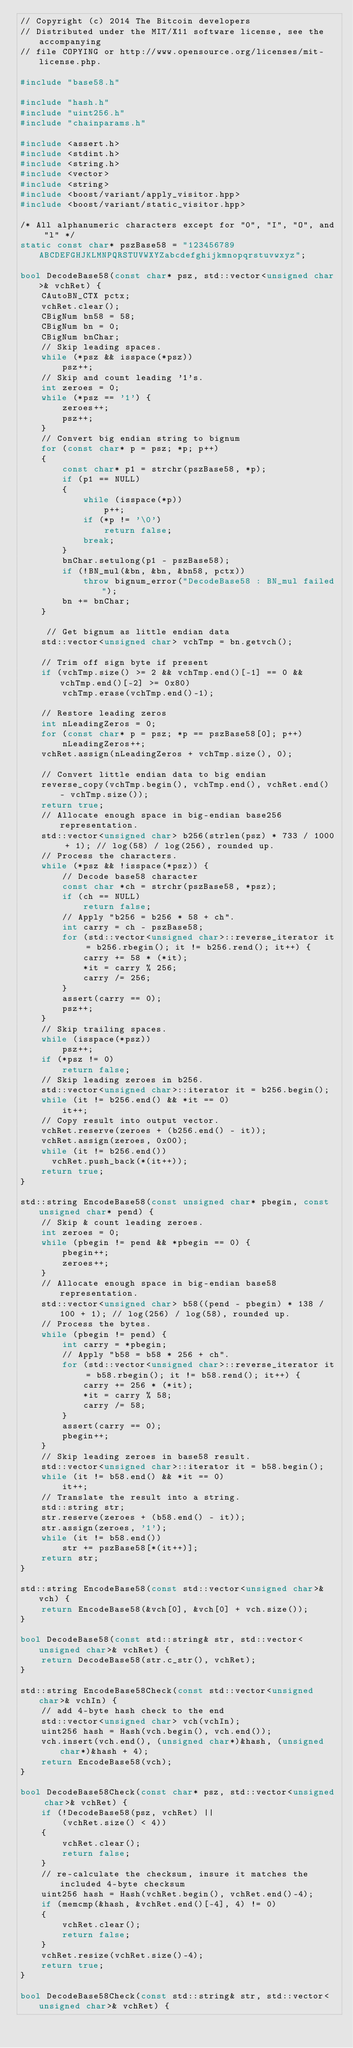<code> <loc_0><loc_0><loc_500><loc_500><_C++_>// Copyright (c) 2014 The Bitcoin developers
// Distributed under the MIT/X11 software license, see the accompanying
// file COPYING or http://www.opensource.org/licenses/mit-license.php.

#include "base58.h"

#include "hash.h"
#include "uint256.h"
#include "chainparams.h"

#include <assert.h>
#include <stdint.h>
#include <string.h>
#include <vector>
#include <string>
#include <boost/variant/apply_visitor.hpp>
#include <boost/variant/static_visitor.hpp>

/* All alphanumeric characters except for "0", "I", "O", and "l" */
static const char* pszBase58 = "123456789ABCDEFGHJKLMNPQRSTUVWXYZabcdefghijkmnopqrstuvwxyz";

bool DecodeBase58(const char* psz, std::vector<unsigned char>& vchRet) {
    CAutoBN_CTX pctx;
    vchRet.clear();
    CBigNum bn58 = 58;
    CBigNum bn = 0;
    CBigNum bnChar;
    // Skip leading spaces.
    while (*psz && isspace(*psz))
        psz++;
    // Skip and count leading '1's.
    int zeroes = 0;
    while (*psz == '1') {
        zeroes++;
        psz++;
    }
    // Convert big endian string to bignum
    for (const char* p = psz; *p; p++)
    {
        const char* p1 = strchr(pszBase58, *p);
        if (p1 == NULL)
        {
            while (isspace(*p))
                p++;
            if (*p != '\0')
                return false;
            break;
        }
        bnChar.setulong(p1 - pszBase58);
        if (!BN_mul(&bn, &bn, &bn58, pctx))
            throw bignum_error("DecodeBase58 : BN_mul failed");
        bn += bnChar;
    }

     // Get bignum as little endian data
    std::vector<unsigned char> vchTmp = bn.getvch();

    // Trim off sign byte if present
    if (vchTmp.size() >= 2 && vchTmp.end()[-1] == 0 && vchTmp.end()[-2] >= 0x80)
        vchTmp.erase(vchTmp.end()-1);

    // Restore leading zeros
    int nLeadingZeros = 0;
    for (const char* p = psz; *p == pszBase58[0]; p++)
        nLeadingZeros++;
    vchRet.assign(nLeadingZeros + vchTmp.size(), 0);

    // Convert little endian data to big endian
    reverse_copy(vchTmp.begin(), vchTmp.end(), vchRet.end() - vchTmp.size());
    return true;
    // Allocate enough space in big-endian base256 representation.
    std::vector<unsigned char> b256(strlen(psz) * 733 / 1000 + 1); // log(58) / log(256), rounded up.
    // Process the characters.
    while (*psz && !isspace(*psz)) {
        // Decode base58 character
        const char *ch = strchr(pszBase58, *psz);
        if (ch == NULL)
            return false;
        // Apply "b256 = b256 * 58 + ch".
        int carry = ch - pszBase58;
        for (std::vector<unsigned char>::reverse_iterator it = b256.rbegin(); it != b256.rend(); it++) {
            carry += 58 * (*it);
            *it = carry % 256;
            carry /= 256;
        }
        assert(carry == 0);
        psz++;
    }
    // Skip trailing spaces.
    while (isspace(*psz))
        psz++;
    if (*psz != 0)
        return false;
    // Skip leading zeroes in b256.
    std::vector<unsigned char>::iterator it = b256.begin();
    while (it != b256.end() && *it == 0)
        it++;
    // Copy result into output vector.
    vchRet.reserve(zeroes + (b256.end() - it));
    vchRet.assign(zeroes, 0x00);
    while (it != b256.end())
      vchRet.push_back(*(it++));
    return true;
}

std::string EncodeBase58(const unsigned char* pbegin, const unsigned char* pend) {
    // Skip & count leading zeroes.
    int zeroes = 0;
    while (pbegin != pend && *pbegin == 0) {
        pbegin++;
        zeroes++;
    }
    // Allocate enough space in big-endian base58 representation.
    std::vector<unsigned char> b58((pend - pbegin) * 138 / 100 + 1); // log(256) / log(58), rounded up.
    // Process the bytes.
    while (pbegin != pend) {
        int carry = *pbegin;
        // Apply "b58 = b58 * 256 + ch".
        for (std::vector<unsigned char>::reverse_iterator it = b58.rbegin(); it != b58.rend(); it++) {
            carry += 256 * (*it);
            *it = carry % 58;
            carry /= 58;
        }
        assert(carry == 0);
        pbegin++;
    }
    // Skip leading zeroes in base58 result.
    std::vector<unsigned char>::iterator it = b58.begin();
    while (it != b58.end() && *it == 0)
        it++;
    // Translate the result into a string.
    std::string str;
    str.reserve(zeroes + (b58.end() - it));
    str.assign(zeroes, '1');
    while (it != b58.end())
        str += pszBase58[*(it++)];
    return str;
}

std::string EncodeBase58(const std::vector<unsigned char>& vch) {
    return EncodeBase58(&vch[0], &vch[0] + vch.size());
}

bool DecodeBase58(const std::string& str, std::vector<unsigned char>& vchRet) {
    return DecodeBase58(str.c_str(), vchRet);
}

std::string EncodeBase58Check(const std::vector<unsigned char>& vchIn) {
    // add 4-byte hash check to the end
    std::vector<unsigned char> vch(vchIn);
    uint256 hash = Hash(vch.begin(), vch.end());
    vch.insert(vch.end(), (unsigned char*)&hash, (unsigned char*)&hash + 4);
    return EncodeBase58(vch);
}

bool DecodeBase58Check(const char* psz, std::vector<unsigned char>& vchRet) {
    if (!DecodeBase58(psz, vchRet) ||
        (vchRet.size() < 4))
    {
        vchRet.clear();
        return false;
    }
    // re-calculate the checksum, insure it matches the included 4-byte checksum
    uint256 hash = Hash(vchRet.begin(), vchRet.end()-4);
    if (memcmp(&hash, &vchRet.end()[-4], 4) != 0)
    {
        vchRet.clear();
        return false;
    }
    vchRet.resize(vchRet.size()-4);
    return true;
}

bool DecodeBase58Check(const std::string& str, std::vector<unsigned char>& vchRet) {</code> 